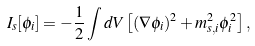Convert formula to latex. <formula><loc_0><loc_0><loc_500><loc_500>I _ { s } [ \phi _ { i } ] = - \frac { 1 } { 2 } \int d V \left [ ( \nabla \phi _ { i } ) ^ { 2 } + m _ { s , i } ^ { 2 } \phi ^ { 2 } _ { i } \right ] ,</formula> 